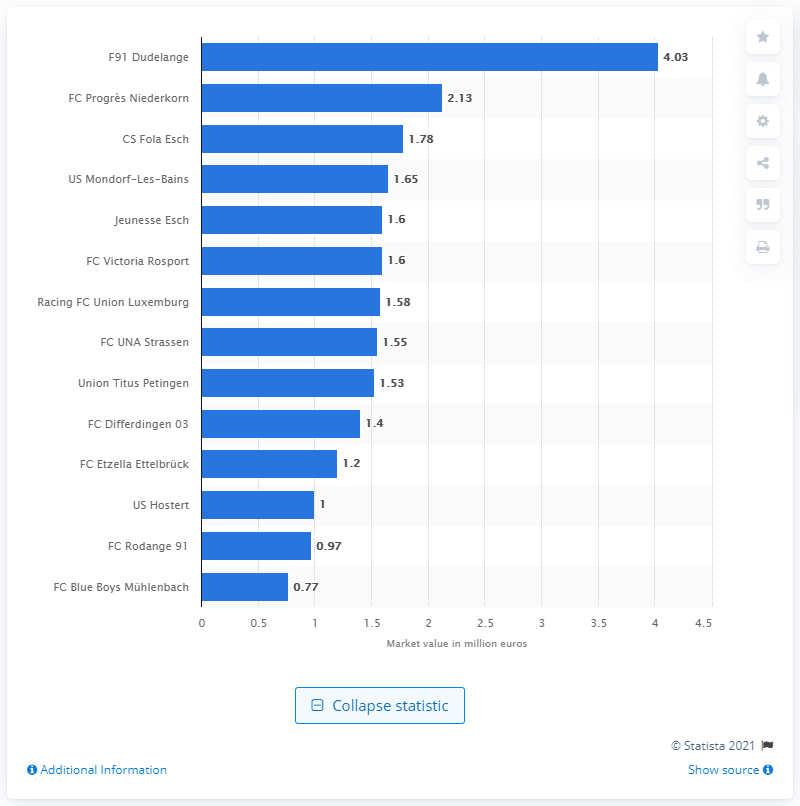Outline some significant characteristics in this image. As of 2019, F91 Dudelange had the highest market value among all teams. 